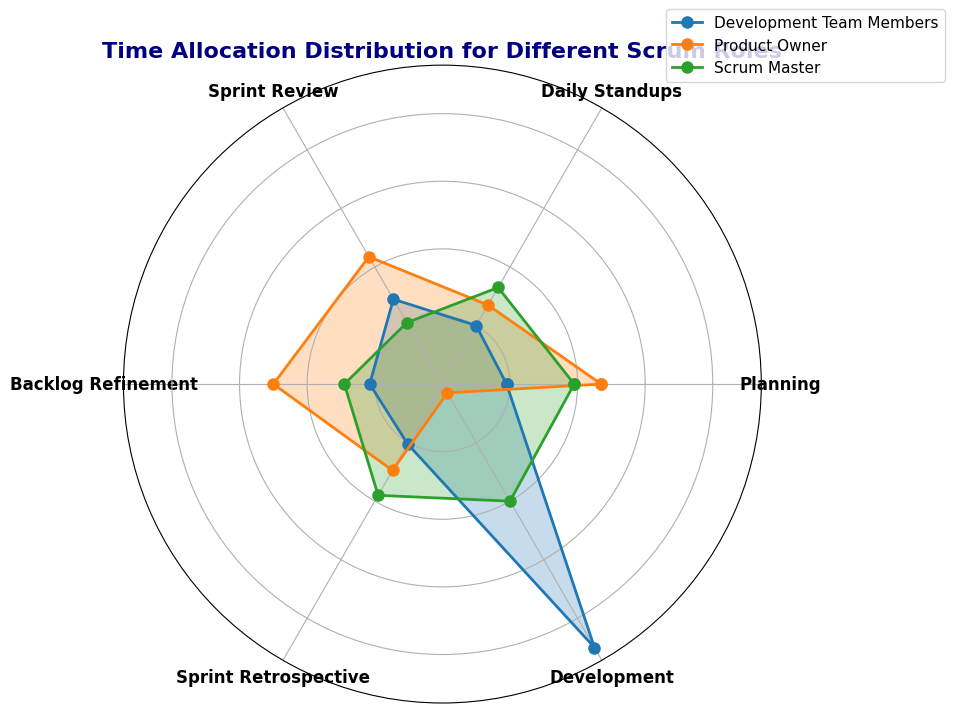What's the average amount of time allocated to Planning by the Scrum Master? First, locate the Planning data point for the Scrum Master from the radar chart. Add the values (20, 18, 19, 21) and divide by the total number of points, which is 4. This gives (20 + 18 + 19 + 21)/4 = 19.5.
Answer: 19.5 Which role spends the most time on Development? Look at the Development data points for each role in the radar chart. The Development Team Members spend the most time on Development with values far exceeding the other roles.
Answer: Development Team Members What is the sum of time spent on Sprint Review and Backlog Refinement by the Product Owner? From the radar chart, locate the values for Sprint Review (22, 24, 22, 21) and Backlog Refinement (25, 26, 25, 24) for the Product Owner. Add these values together: Sum of Sprint Review = 22 + 24 + 22 + 21 = 89, Backlog Refinement = 25 + 26 + 25 + 24 = 100. Thus, the total is 89 + 100 = 189.
Answer: 189 Which role has the least variation in time allocated to Daily Standups? Compare the data points for Daily Standups across all roles. The Development Team Members have the smallest variation, with values of 10, 9, 10, 11, indicating the least fluctuation.
Answer: Development Team Members On average, do Scrum Masters or Development Team Members spend more time on Sprint Retrospective? Calculate the average time for Sprint Retrospective for Scrum Masters (20, 18, 20, 18 = 76/4 = 19.0) and Development Team Members (10, 11, 11, 9 = 41/4 = 10.25). Comparing these averages, Scrum Masters spend more time.
Answer: Scrum Masters Which role's time allocation remains zero for Development? From the radar chart, the Product Owner's data points for Development always remain zero, indicating no time is spent on Development.
Answer: Product Owner What is the difference in average time spent on Standups between the Scrum Master and Product Owner? Calculate the average time for Standups: Scrum Master (15, 18, 17, 16 = 66/4 = 16.5) and Product Owner (15, 12, 14, 13 = 54/4 = 13.5). The difference is 16.5 - 13.5 = 3.
Answer: 3 Which activity shows the most similar time allocation between Scrum Masters and Product Owners? Compare the time values for various activities between Scrum Masters and Product Owners across the radar chart. The Planning activity has close values: Scrum Master (20, 18, 19, 21) and Product Owner (25, 22, 23, 24).
Answer: Planning Do Development Team Members spend more time on Sprint Review or Sprint Retrospective? Compare the Sprint Review (15, 14, 13, 16) with the Sprint Retrospective (10, 11, 11, 9) for Development Team Members. Summing the values yields Sprint Review = 58 and Sprint Retrospective = 41. Thus, Development Team Members spend more time on Sprint Review.
Answer: Sprint Review 